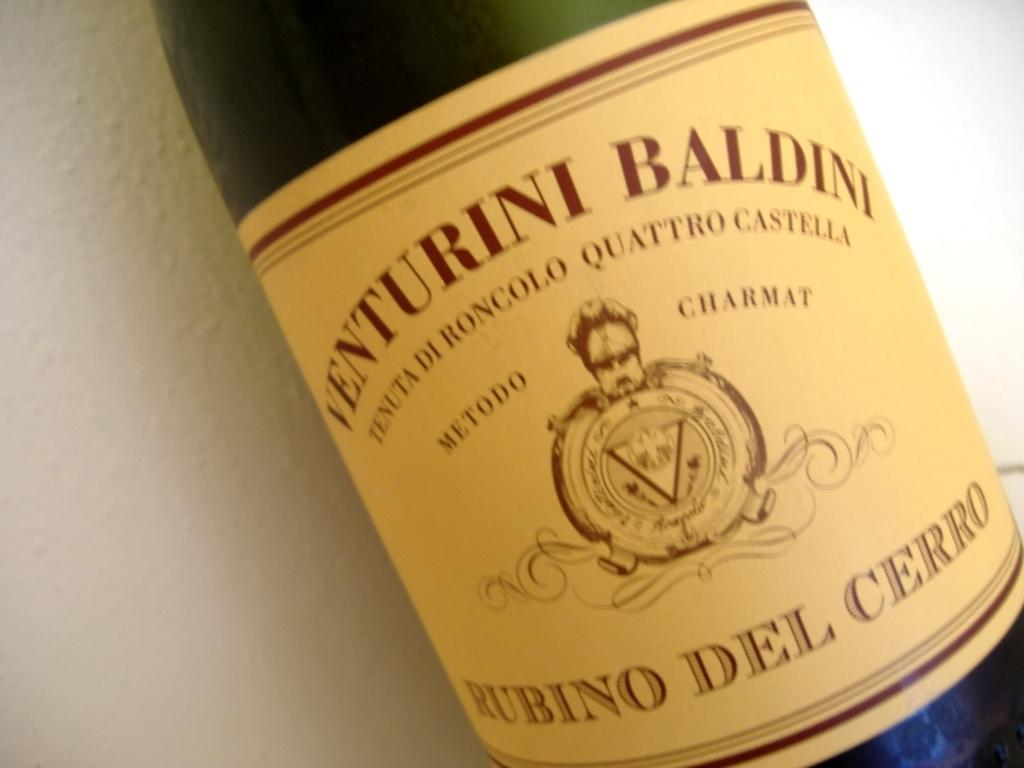What is the main object in the center of the image? There is a bottle in the center of the image. Where is the bottle located? The bottle is on a surface. What can be seen on the bottle besides its shape? There is text and a logo on the bottle. What type of frame is around the bottle in the image? There is no frame around the bottle in the image. Can you describe how the bottle moves in the image? The bottle does not move in the image; it is stationary on the surface. 